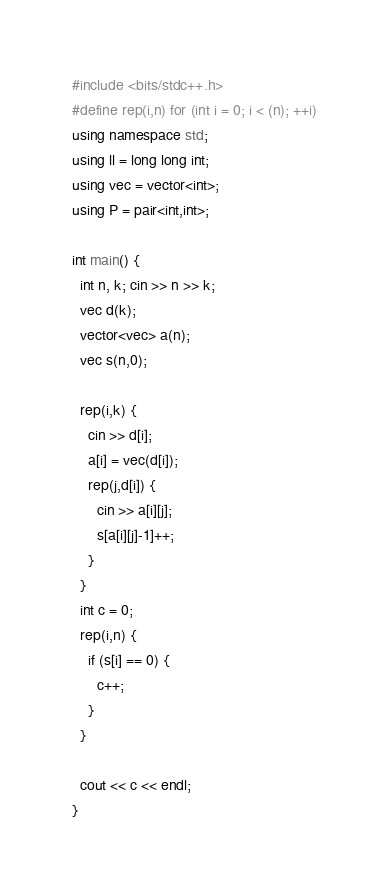<code> <loc_0><loc_0><loc_500><loc_500><_C++_>#include <bits/stdc++.h>
#define rep(i,n) for (int i = 0; i < (n); ++i)
using namespace std;
using ll = long long int;
using vec = vector<int>;
using P = pair<int,int>;

int main() {
  int n, k; cin >> n >> k;
  vec d(k);
  vector<vec> a(n);
  vec s(n,0);
  
  rep(i,k) {
    cin >> d[i];
    a[i] = vec(d[i]);
    rep(j,d[i]) {
      cin >> a[i][j];
      s[a[i][j]-1]++;
    }
  }
  int c = 0;
  rep(i,n) {
    if (s[i] == 0) {
      c++;
    }
  }

  cout << c << endl;
}
</code> 